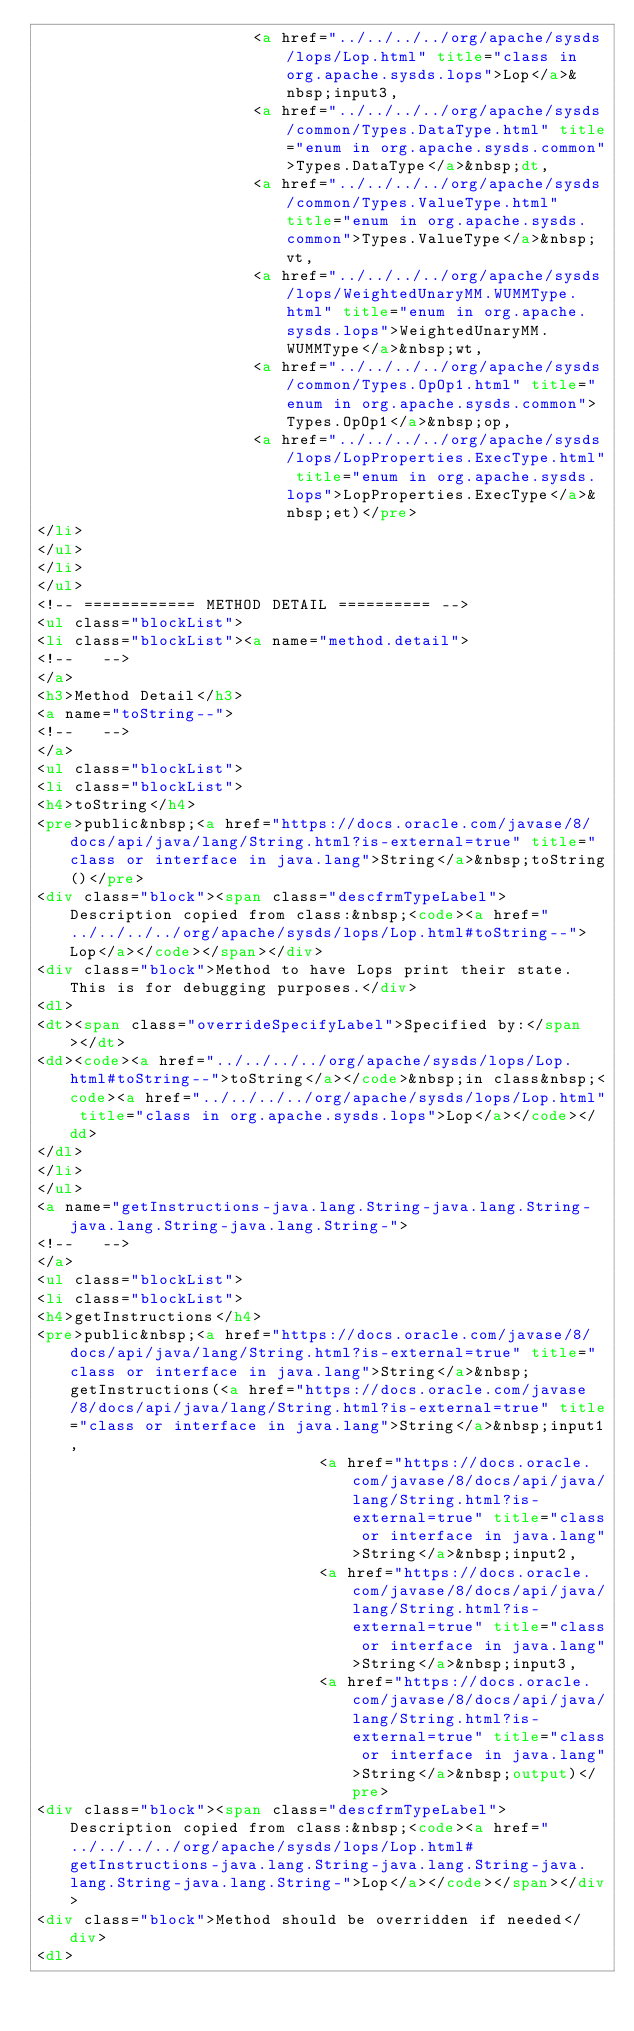<code> <loc_0><loc_0><loc_500><loc_500><_HTML_>                       <a href="../../../../org/apache/sysds/lops/Lop.html" title="class in org.apache.sysds.lops">Lop</a>&nbsp;input3,
                       <a href="../../../../org/apache/sysds/common/Types.DataType.html" title="enum in org.apache.sysds.common">Types.DataType</a>&nbsp;dt,
                       <a href="../../../../org/apache/sysds/common/Types.ValueType.html" title="enum in org.apache.sysds.common">Types.ValueType</a>&nbsp;vt,
                       <a href="../../../../org/apache/sysds/lops/WeightedUnaryMM.WUMMType.html" title="enum in org.apache.sysds.lops">WeightedUnaryMM.WUMMType</a>&nbsp;wt,
                       <a href="../../../../org/apache/sysds/common/Types.OpOp1.html" title="enum in org.apache.sysds.common">Types.OpOp1</a>&nbsp;op,
                       <a href="../../../../org/apache/sysds/lops/LopProperties.ExecType.html" title="enum in org.apache.sysds.lops">LopProperties.ExecType</a>&nbsp;et)</pre>
</li>
</ul>
</li>
</ul>
<!-- ============ METHOD DETAIL ========== -->
<ul class="blockList">
<li class="blockList"><a name="method.detail">
<!--   -->
</a>
<h3>Method Detail</h3>
<a name="toString--">
<!--   -->
</a>
<ul class="blockList">
<li class="blockList">
<h4>toString</h4>
<pre>public&nbsp;<a href="https://docs.oracle.com/javase/8/docs/api/java/lang/String.html?is-external=true" title="class or interface in java.lang">String</a>&nbsp;toString()</pre>
<div class="block"><span class="descfrmTypeLabel">Description copied from class:&nbsp;<code><a href="../../../../org/apache/sysds/lops/Lop.html#toString--">Lop</a></code></span></div>
<div class="block">Method to have Lops print their state. This is for debugging purposes.</div>
<dl>
<dt><span class="overrideSpecifyLabel">Specified by:</span></dt>
<dd><code><a href="../../../../org/apache/sysds/lops/Lop.html#toString--">toString</a></code>&nbsp;in class&nbsp;<code><a href="../../../../org/apache/sysds/lops/Lop.html" title="class in org.apache.sysds.lops">Lop</a></code></dd>
</dl>
</li>
</ul>
<a name="getInstructions-java.lang.String-java.lang.String-java.lang.String-java.lang.String-">
<!--   -->
</a>
<ul class="blockList">
<li class="blockList">
<h4>getInstructions</h4>
<pre>public&nbsp;<a href="https://docs.oracle.com/javase/8/docs/api/java/lang/String.html?is-external=true" title="class or interface in java.lang">String</a>&nbsp;getInstructions(<a href="https://docs.oracle.com/javase/8/docs/api/java/lang/String.html?is-external=true" title="class or interface in java.lang">String</a>&nbsp;input1,
                              <a href="https://docs.oracle.com/javase/8/docs/api/java/lang/String.html?is-external=true" title="class or interface in java.lang">String</a>&nbsp;input2,
                              <a href="https://docs.oracle.com/javase/8/docs/api/java/lang/String.html?is-external=true" title="class or interface in java.lang">String</a>&nbsp;input3,
                              <a href="https://docs.oracle.com/javase/8/docs/api/java/lang/String.html?is-external=true" title="class or interface in java.lang">String</a>&nbsp;output)</pre>
<div class="block"><span class="descfrmTypeLabel">Description copied from class:&nbsp;<code><a href="../../../../org/apache/sysds/lops/Lop.html#getInstructions-java.lang.String-java.lang.String-java.lang.String-java.lang.String-">Lop</a></code></span></div>
<div class="block">Method should be overridden if needed</div>
<dl></code> 